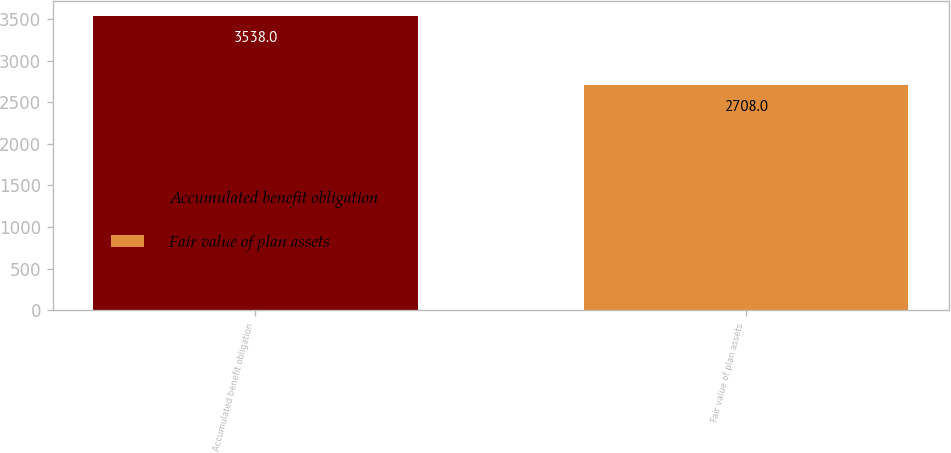Convert chart to OTSL. <chart><loc_0><loc_0><loc_500><loc_500><bar_chart><fcel>Accumulated benefit obligation<fcel>Fair value of plan assets<nl><fcel>3538<fcel>2708<nl></chart> 